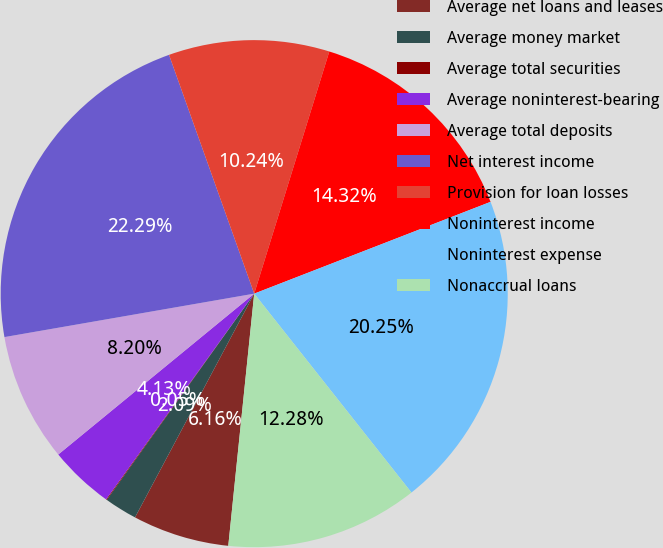<chart> <loc_0><loc_0><loc_500><loc_500><pie_chart><fcel>Average net loans and leases<fcel>Average money market<fcel>Average total securities<fcel>Average noninterest-bearing<fcel>Average total deposits<fcel>Net interest income<fcel>Provision for loan losses<fcel>Noninterest income<fcel>Noninterest expense<fcel>Nonaccrual loans<nl><fcel>6.16%<fcel>2.09%<fcel>0.05%<fcel>4.13%<fcel>8.2%<fcel>22.29%<fcel>10.24%<fcel>14.32%<fcel>20.25%<fcel>12.28%<nl></chart> 